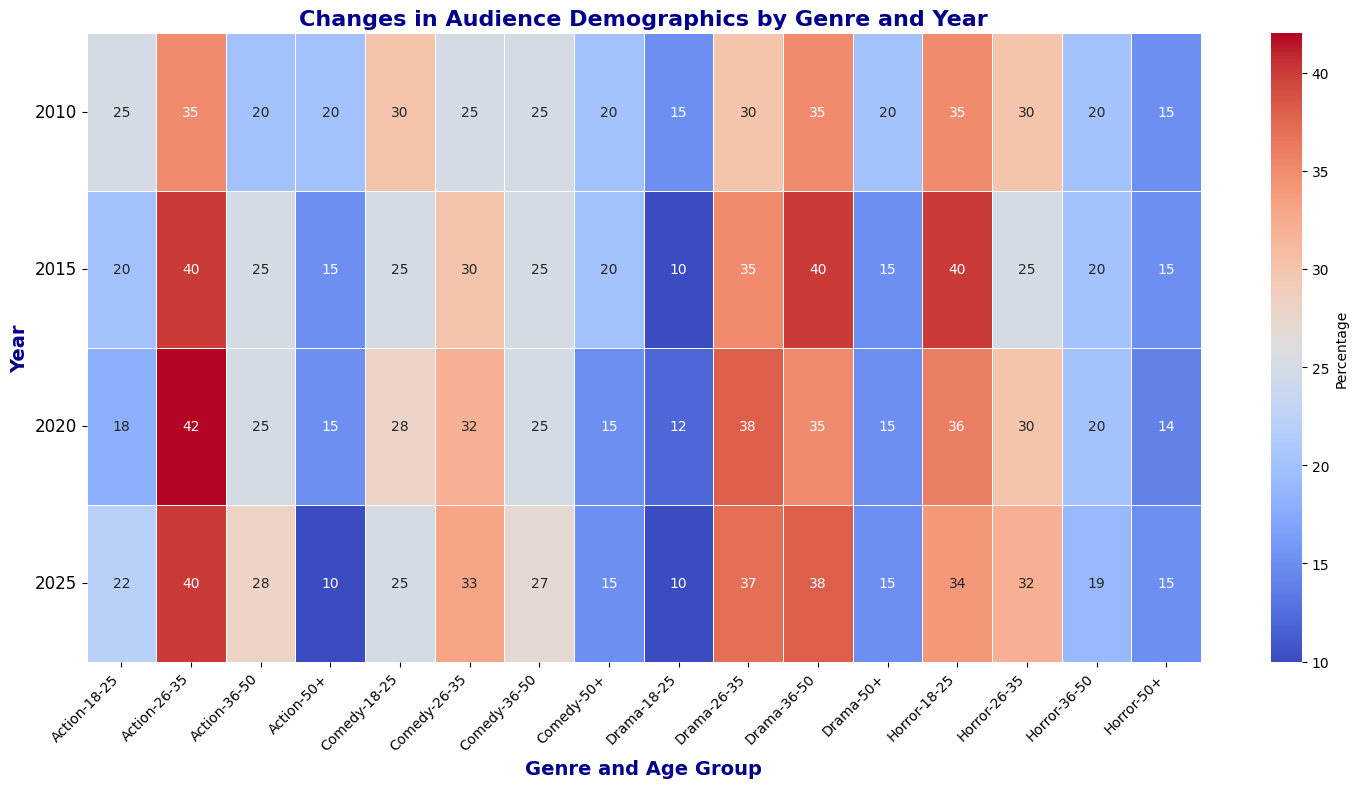What was the trend in the percentage of 26-35-year-olds watching Action movies from 2010 to 2025? To find the trend, look at the percentages for 26-35-year-olds in the 'Action' genre for each year (2010, 2015, 2020, 2025). The percentages are 35% in 2010, 40% in 2015, 42% in 2020, and 40% in 2025. Visually, this shows an initial increase from 2010 to 2020, followed by a slight decrease in 2025.
Answer: Increasing (2010-2020) then decreasing (2025) Which genre had the highest percentage of 18-25-year-olds in 2025? Check the values for the 18-25 age group across all genres for the year 2025. The values are 22 (Action), 25 (Comedy), 10 (Drama), and 34 (Horror). The highest percentage is for Horror.
Answer: Horror How has the interest in Drama movies by the 36-50 age group changed from 2010 to 2025? Look at the percentage values for the 36-50 age group for Drama in each of the specified years (2010, 2015, 2020, 2025). These are 35% in 2010, 40% in 2015, 35% in 2020, and 38% in 2025. The interest increased from 2010 to 2015, then slightly decreased from 2015 to 2020, and increased again from 2020 to 2025.
Answer: Increased, then decreased, then increased Compare the percentage of 26-35-year-olds watching Comedy and Action movies in 2020. Which is higher? Look at the percentages for the 26-35 age group in the year 2020 for Comedy and Action genres. For Comedy, it is 32%, and for Action, it is 42%. Action has a higher percentage.
Answer: Action What is the average percentage of 18-25-year-olds watching Horror movies from 2010 to 2025? First, collect the 18-25 percentages for Horror from 2010 to 2025: 35%, 40%, 36%, 34%. Sum these values: (35 + 40 + 36 + 34) = 145. Divide by the number of years (4) to get the average: 145/4 = 36.25%.
Answer: 36.25% In which year did the 36-50 age group have the highest percentage for Comedy movies? Check all the values for the 36-50 age group in Comedy for each year: 25% in 2010, 25% in 2015, 25% in 2020, 27% in 2025. The highest percentage is in 2025.
Answer: 2025 Is there a noticeable trend in the percentage of 18-25-year-olds watching Drama movies from 2010 to 2025? Look at the values for the 18-25 age group for Drama in the specified years: 15% in 2010, 10% in 2015, 12% in 2020, and 10% in 2025. There is a noticeable downward trend with a slight increase in 2020.
Answer: Decreasing What is the overall trend in percentages of the 50+ age group watching any genre from 2010 to 2025? Visually examine the 50+ age group's percentages across all genres for each year. Most genres (Action, Comedy, Drama, Horror) show a slight decrease or stable low values from 2010 to 2025. Typically, values are shifting down or remaining steady with small fluctuations.
Answer: Decreasing or stable Which genre experienced the most significant increase in viewership among the 26-35 age group between 2010 and 2025? Calculate the difference in percentages for the 26-35 age group for all genres between 2010 and 2025: Action (40-35 = 5), Comedy (33-25 = 8), Drama (37-30 = 7), Horror (32-30 = 2). Comedy saw the most significant increase.
Answer: Comedy 